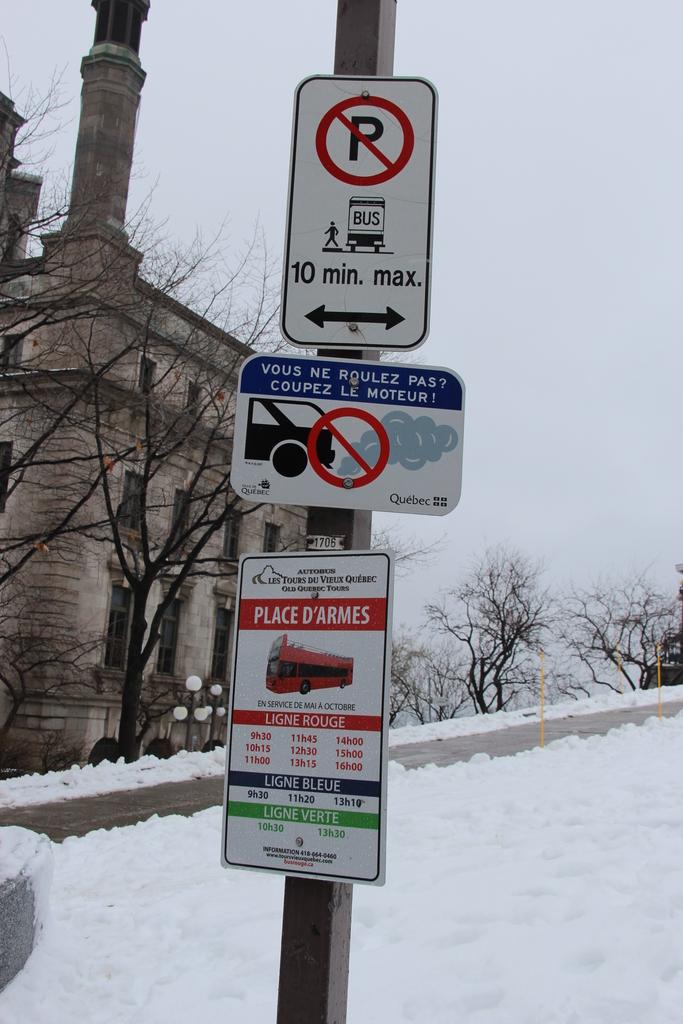How many minutes max on the top sign?
Keep it short and to the point. 10. 